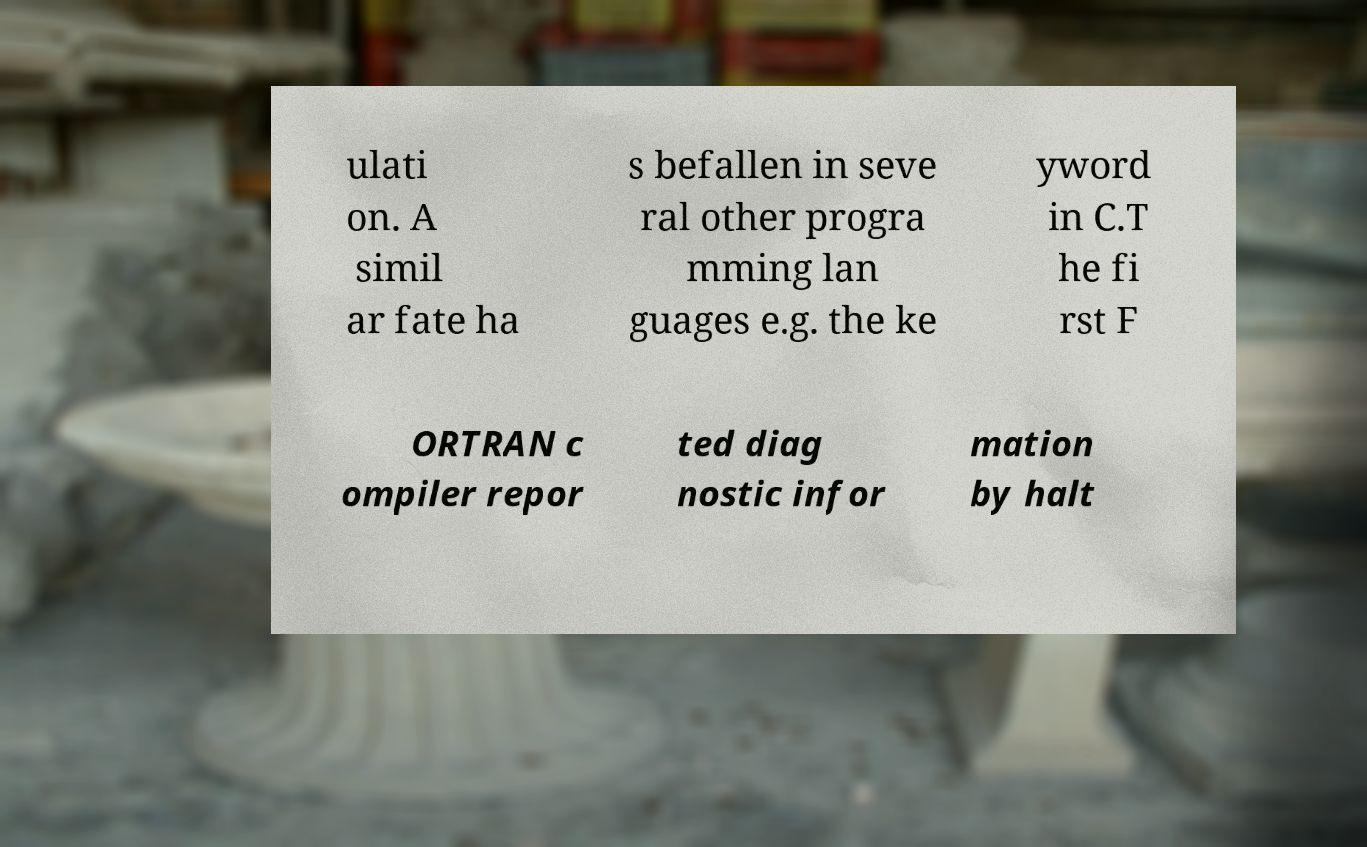Could you extract and type out the text from this image? ulati on. A simil ar fate ha s befallen in seve ral other progra mming lan guages e.g. the ke yword in C.T he fi rst F ORTRAN c ompiler repor ted diag nostic infor mation by halt 